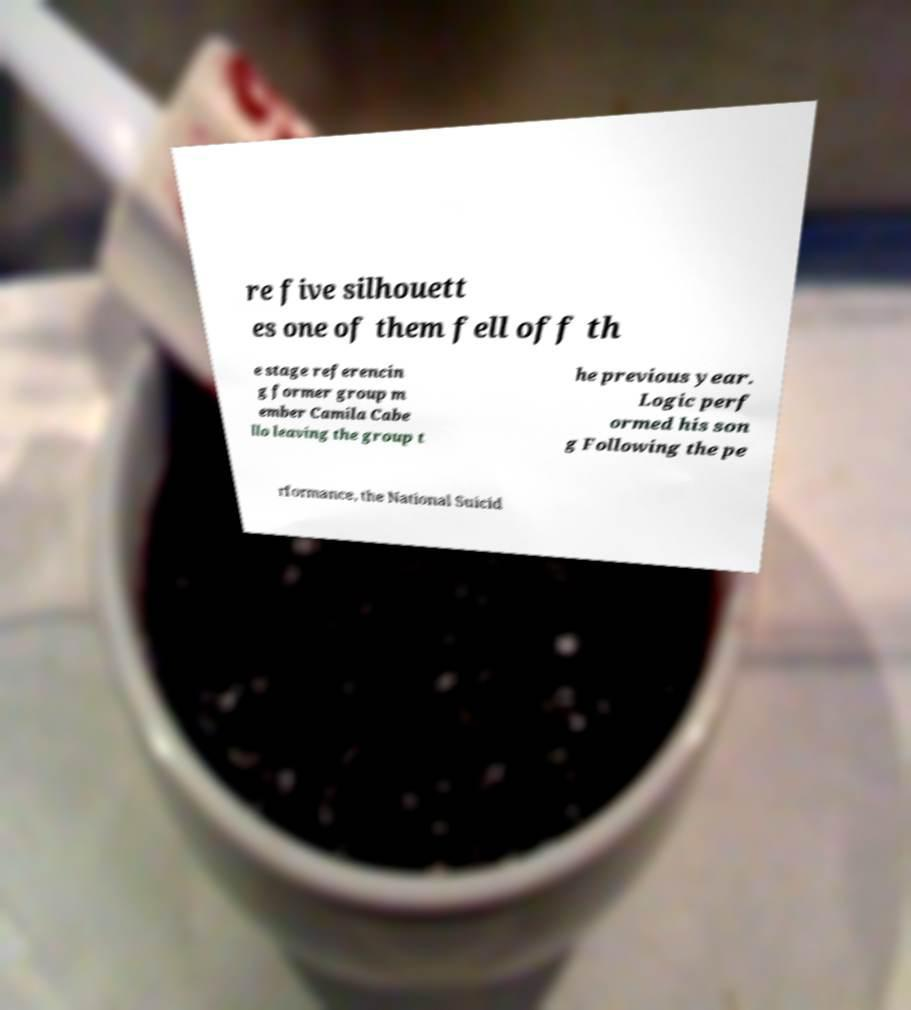Could you extract and type out the text from this image? re five silhouett es one of them fell off th e stage referencin g former group m ember Camila Cabe llo leaving the group t he previous year. Logic perf ormed his son g Following the pe rformance, the National Suicid 